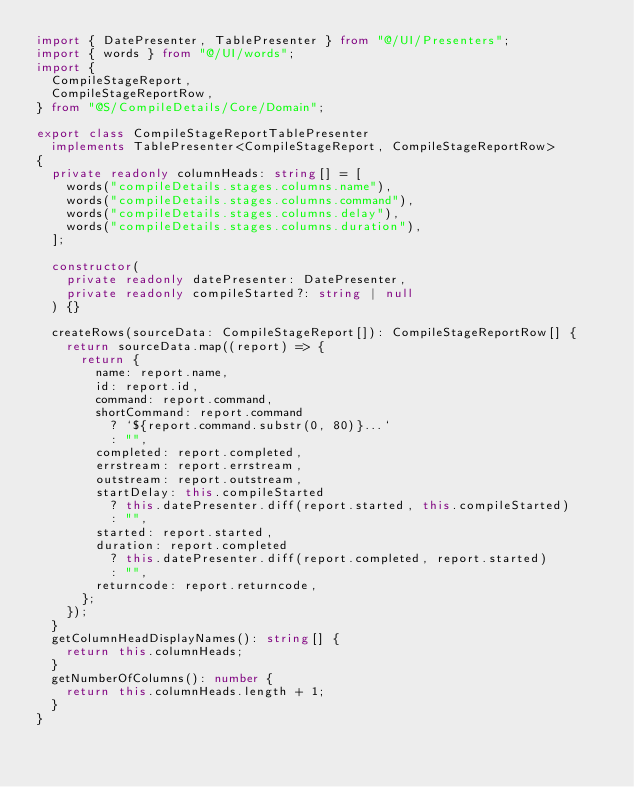<code> <loc_0><loc_0><loc_500><loc_500><_TypeScript_>import { DatePresenter, TablePresenter } from "@/UI/Presenters";
import { words } from "@/UI/words";
import {
  CompileStageReport,
  CompileStageReportRow,
} from "@S/CompileDetails/Core/Domain";

export class CompileStageReportTablePresenter
  implements TablePresenter<CompileStageReport, CompileStageReportRow>
{
  private readonly columnHeads: string[] = [
    words("compileDetails.stages.columns.name"),
    words("compileDetails.stages.columns.command"),
    words("compileDetails.stages.columns.delay"),
    words("compileDetails.stages.columns.duration"),
  ];

  constructor(
    private readonly datePresenter: DatePresenter,
    private readonly compileStarted?: string | null
  ) {}

  createRows(sourceData: CompileStageReport[]): CompileStageReportRow[] {
    return sourceData.map((report) => {
      return {
        name: report.name,
        id: report.id,
        command: report.command,
        shortCommand: report.command
          ? `${report.command.substr(0, 80)}...`
          : "",
        completed: report.completed,
        errstream: report.errstream,
        outstream: report.outstream,
        startDelay: this.compileStarted
          ? this.datePresenter.diff(report.started, this.compileStarted)
          : "",
        started: report.started,
        duration: report.completed
          ? this.datePresenter.diff(report.completed, report.started)
          : "",
        returncode: report.returncode,
      };
    });
  }
  getColumnHeadDisplayNames(): string[] {
    return this.columnHeads;
  }
  getNumberOfColumns(): number {
    return this.columnHeads.length + 1;
  }
}
</code> 